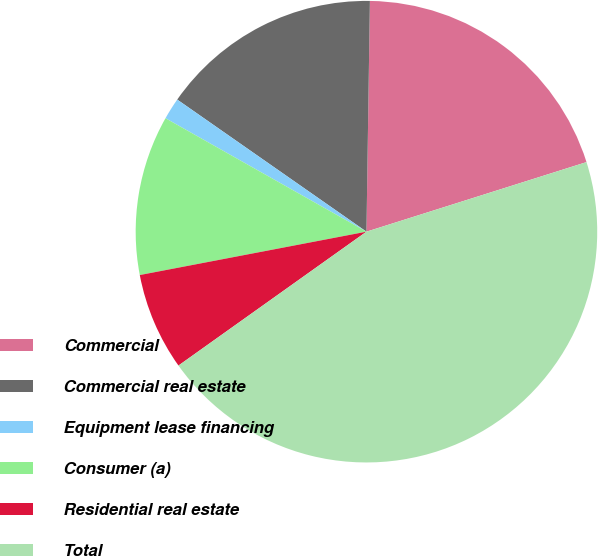Convert chart. <chart><loc_0><loc_0><loc_500><loc_500><pie_chart><fcel>Commercial<fcel>Commercial real estate<fcel>Equipment lease financing<fcel>Consumer (a)<fcel>Residential real estate<fcel>Total<nl><fcel>19.89%<fcel>15.54%<fcel>1.52%<fcel>11.19%<fcel>6.84%<fcel>45.03%<nl></chart> 